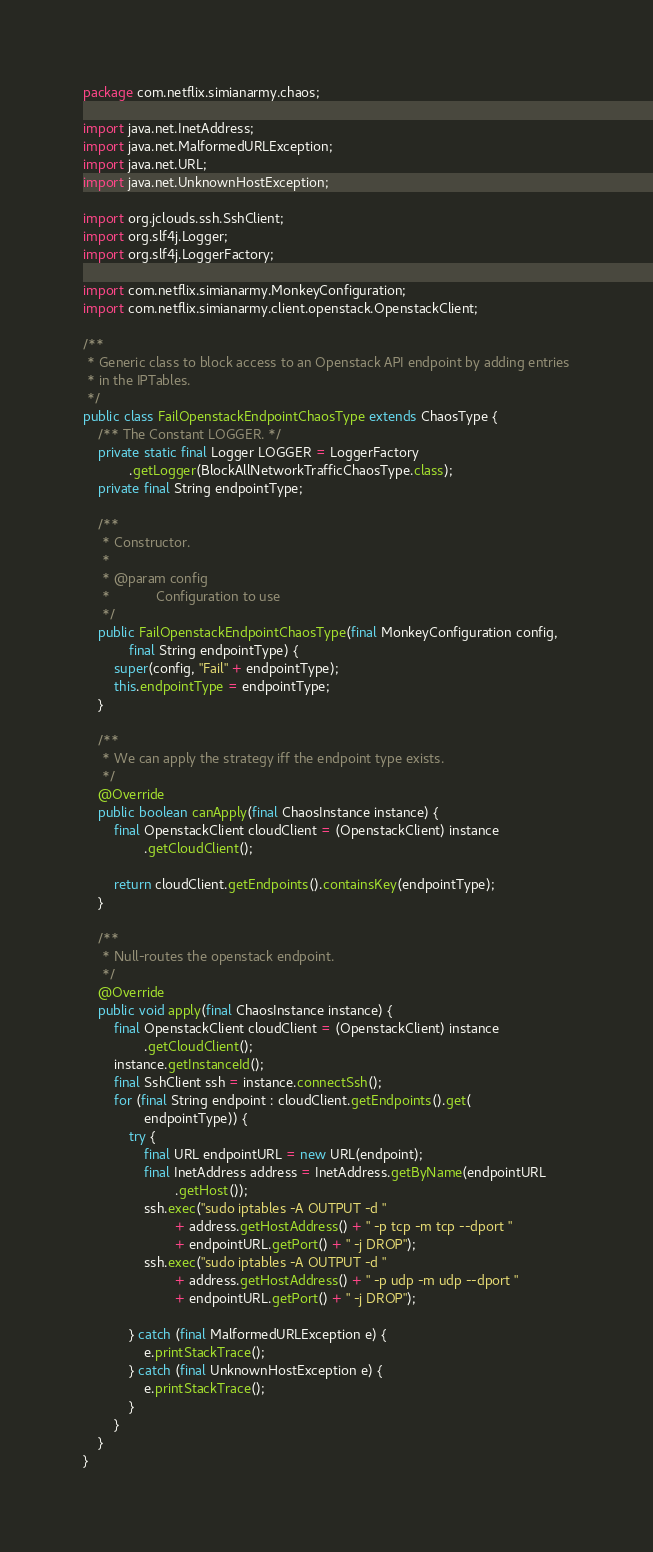Convert code to text. <code><loc_0><loc_0><loc_500><loc_500><_Java_>package com.netflix.simianarmy.chaos;

import java.net.InetAddress;
import java.net.MalformedURLException;
import java.net.URL;
import java.net.UnknownHostException;

import org.jclouds.ssh.SshClient;
import org.slf4j.Logger;
import org.slf4j.LoggerFactory;

import com.netflix.simianarmy.MonkeyConfiguration;
import com.netflix.simianarmy.client.openstack.OpenstackClient;

/**
 * Generic class to block access to an Openstack API endpoint by adding entries
 * in the IPTables.
 */
public class FailOpenstackEndpointChaosType extends ChaosType {
    /** The Constant LOGGER. */
    private static final Logger LOGGER = LoggerFactory
            .getLogger(BlockAllNetworkTrafficChaosType.class);
    private final String endpointType;

    /**
     * Constructor.
     *
     * @param config
     *            Configuration to use
     */
    public FailOpenstackEndpointChaosType(final MonkeyConfiguration config,
            final String endpointType) {
        super(config, "Fail" + endpointType);
        this.endpointType = endpointType;
    }

    /**
     * We can apply the strategy iff the endpoint type exists.
     */
    @Override
    public boolean canApply(final ChaosInstance instance) {
        final OpenstackClient cloudClient = (OpenstackClient) instance
                .getCloudClient();

        return cloudClient.getEndpoints().containsKey(endpointType);
    }

    /**
     * Null-routes the openstack endpoint.
     */
    @Override
    public void apply(final ChaosInstance instance) {
        final OpenstackClient cloudClient = (OpenstackClient) instance
                .getCloudClient();
        instance.getInstanceId();
        final SshClient ssh = instance.connectSsh();
        for (final String endpoint : cloudClient.getEndpoints().get(
                endpointType)) {
            try {
                final URL endpointURL = new URL(endpoint);
                final InetAddress address = InetAddress.getByName(endpointURL
                        .getHost());
                ssh.exec("sudo iptables -A OUTPUT -d "
                        + address.getHostAddress() + " -p tcp -m tcp --dport "
                        + endpointURL.getPort() + " -j DROP");
                ssh.exec("sudo iptables -A OUTPUT -d "
                        + address.getHostAddress() + " -p udp -m udp --dport "
                        + endpointURL.getPort() + " -j DROP");

            } catch (final MalformedURLException e) {
                e.printStackTrace();
            } catch (final UnknownHostException e) {
                e.printStackTrace();
            }
        }
    }
}

</code> 